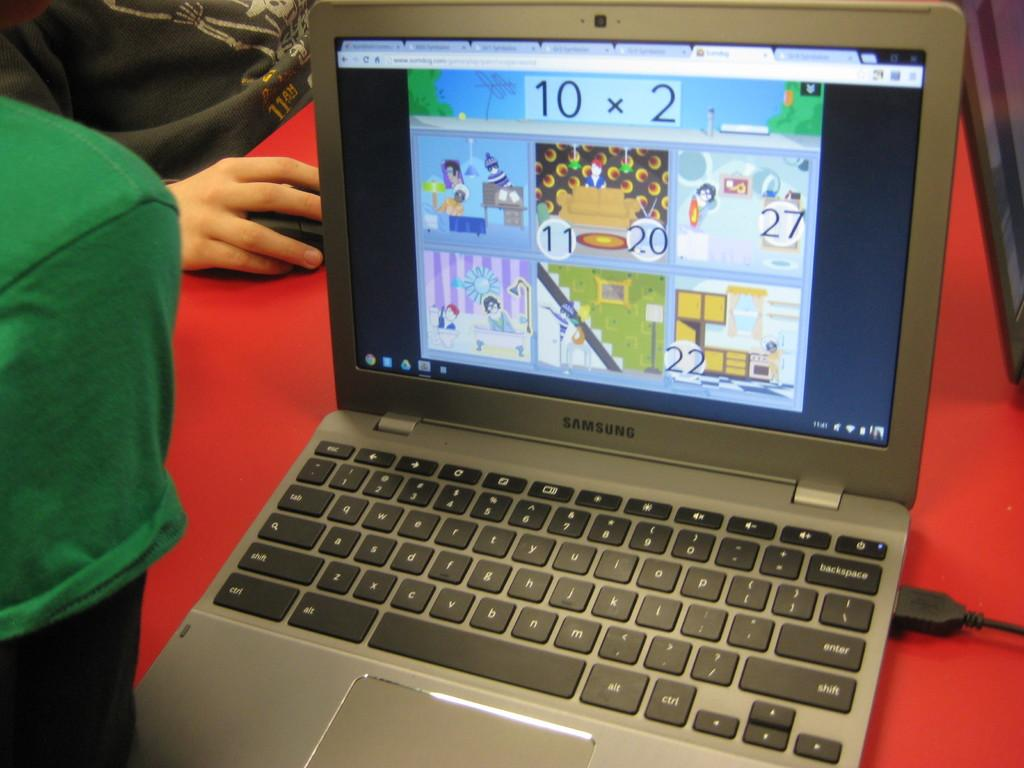<image>
Render a clear and concise summary of the photo. a laptop displaying what appears to be child math games 